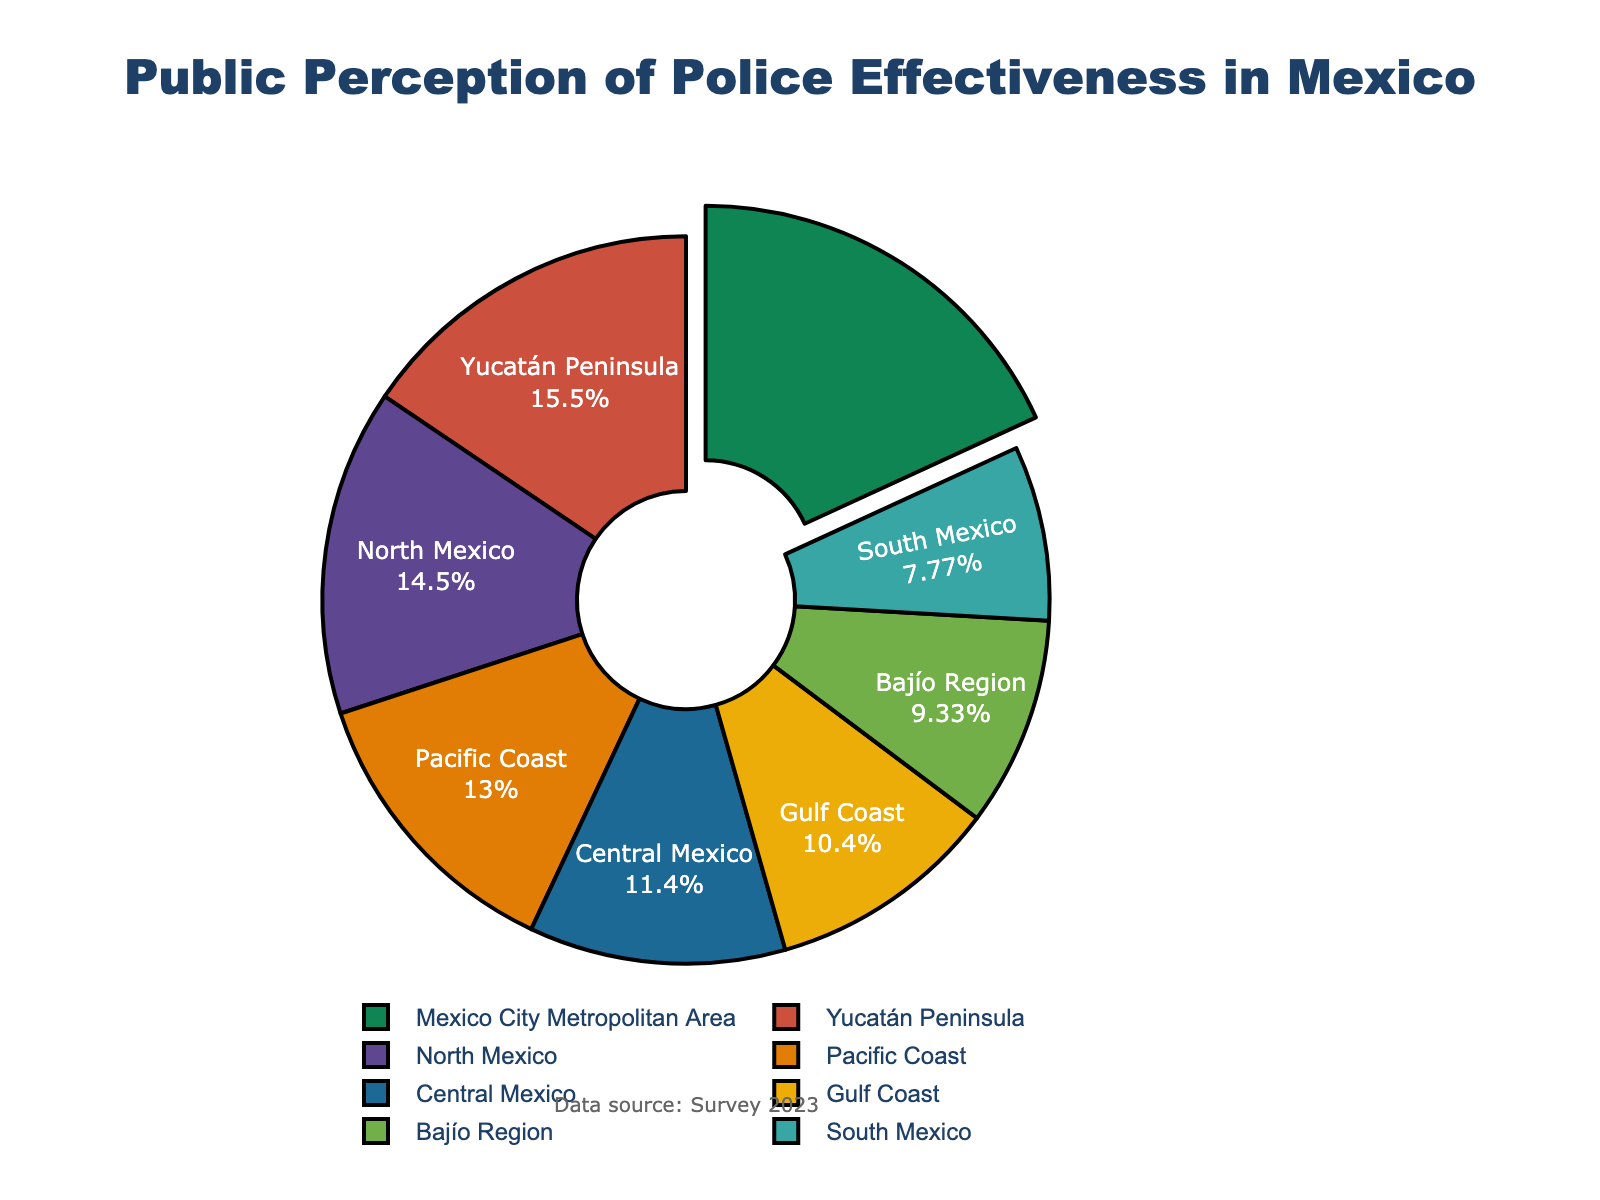What's the region with the highest public perception of police effectiveness? To determine which region has the highest public perception, we look for the region with the largest percentage slice. According to the chart, the Mexico City Metropolitan Area has the largest slice.
Answer: Mexico City Metropolitan Area Which region has the second highest public perception after Mexico City Metropolitan Area? First, we identify the highest value, which is the Mexico City Metropolitan Area at 35%. The next highest value is for the Yucatán Peninsula, which has 30%.
Answer: Yucatán Peninsula What's the combined percentage of North and Central Mexico? Adding the percentages for North Mexico (28%) and Central Mexico (22%) gives us 28 + 22 = 50.
Answer: 50% How does the perception in the Gulf Coast compare to the Pacific Coast? The chart shows the Gulf Coast at 20% and the Pacific Coast at 25%. Comparing these, the Pacific Coast is higher by 5%.
Answer: The Pacific Coast is higher by 5% Which region represents the smallest perception of police effectiveness? The smallest percentage slice on the pie chart belongs to the South Mexico, which has 15%.
Answer: South Mexico What's the total percentage for regions with less than 25% perception? Adding the percentages for Central Mexico (22%), Gulf Coast (20%), Bajío Region (18%), and South Mexico (15%) gives 22 + 20 + 18 + 15 = 75.
Answer: 75% Is the percentage perception of the Yucatán Peninsula above or below 25%? The chart shows the Yucatán Peninsula with a 30% slice, which is above 25%.
Answer: Above 25% Which regions together make up more than half of the total percentage? The total percentage is 100%. Mexico City Metropolitan Area (35%) and Yucatán Peninsula (30%) together make 35 + 30 = 65, which is more than half.
Answer: Mexico City Metropolitan Area and Yucatán Peninsula What is the difference in percentage perception between the Bajío Region and North Mexico? The chart shows the Bajío Region at 18% and North Mexico at 28%. The difference is 28 - 18 = 10.
Answer: 10% Which region has a visually distinct slice due to being pulled out from the rest of the pie chart? A visually distinct slice is created by pulling it out from the rest of the pie chart, which is done for the region with the highest percentage, the Mexico City Metropolitan Area.
Answer: Mexico City Metropolitan Area 